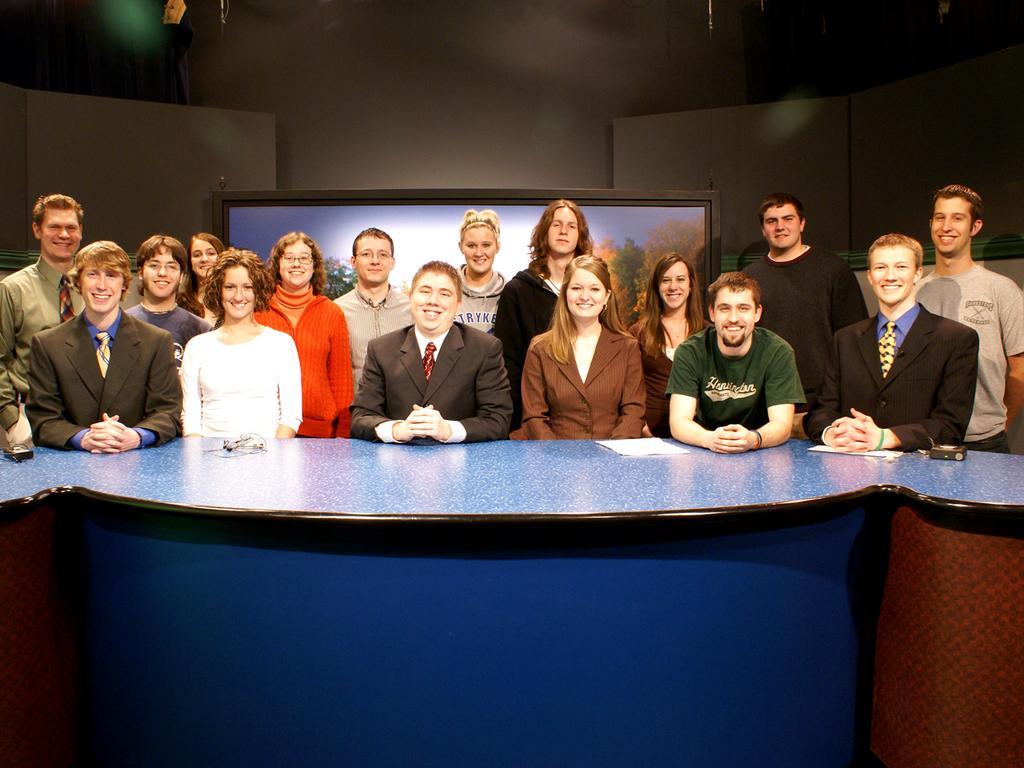Please provide a concise description of this image. This image is clicked in a room, there is a table in the middle of the image which is of blue color and there are so many people standing near the table, behind them there is a screen which has trees in that there is a light in the top left corner ,there are women and man standing near the table, there is a paper on the table. 